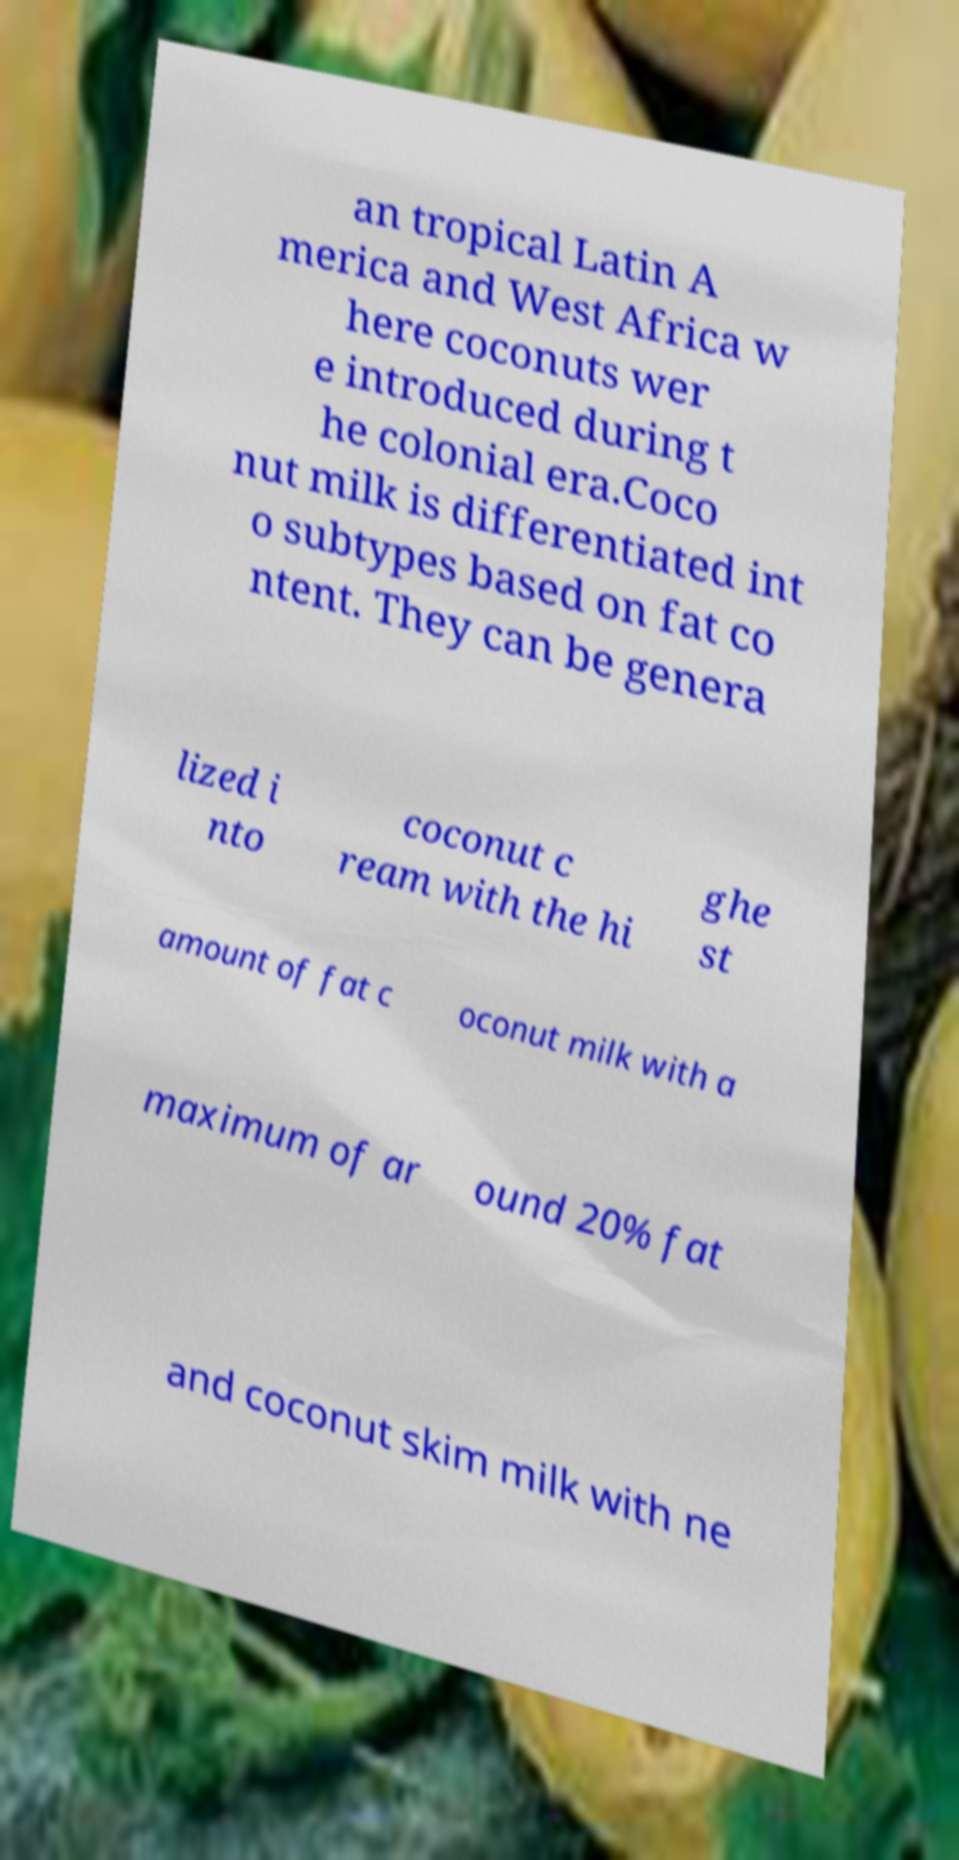I need the written content from this picture converted into text. Can you do that? an tropical Latin A merica and West Africa w here coconuts wer e introduced during t he colonial era.Coco nut milk is differentiated int o subtypes based on fat co ntent. They can be genera lized i nto coconut c ream with the hi ghe st amount of fat c oconut milk with a maximum of ar ound 20% fat and coconut skim milk with ne 